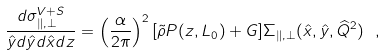<formula> <loc_0><loc_0><loc_500><loc_500>\frac { d \sigma ^ { V + S } _ { \| , \bot } } { \hat { y } d \hat { y } d \hat { x } d z } = \left ( \frac { \alpha } { 2 \pi } \right ) ^ { 2 } [ \tilde { \rho } P ( z , L _ { 0 } ) + G ] \Sigma _ { \| , \bot } ( \hat { x } , \hat { y } , \widehat { Q } ^ { 2 } ) \ ,</formula> 